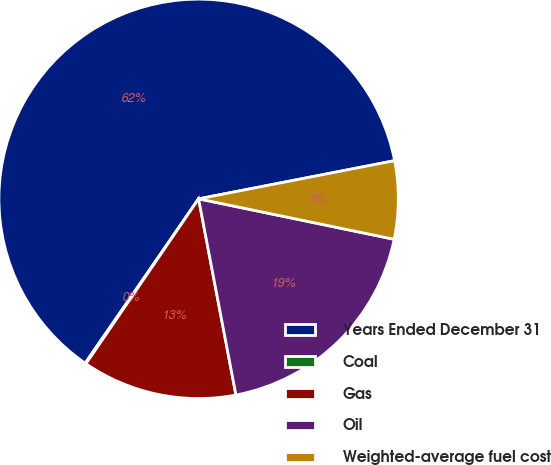Convert chart to OTSL. <chart><loc_0><loc_0><loc_500><loc_500><pie_chart><fcel>Years Ended December 31<fcel>Coal<fcel>Gas<fcel>Oil<fcel>Weighted-average fuel cost<nl><fcel>62.32%<fcel>0.08%<fcel>12.53%<fcel>18.76%<fcel>6.31%<nl></chart> 